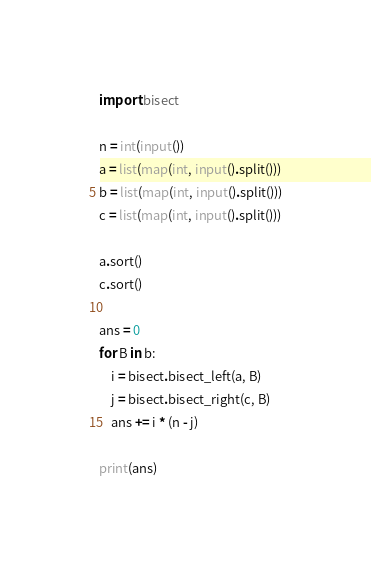Convert code to text. <code><loc_0><loc_0><loc_500><loc_500><_Python_>import bisect

n = int(input())
a = list(map(int, input().split()))
b = list(map(int, input().split()))
c = list(map(int, input().split()))

a.sort()
c.sort()

ans = 0
for B in b:
    i = bisect.bisect_left(a, B)
    j = bisect.bisect_right(c, B)
    ans += i * (n - j)

print(ans)</code> 